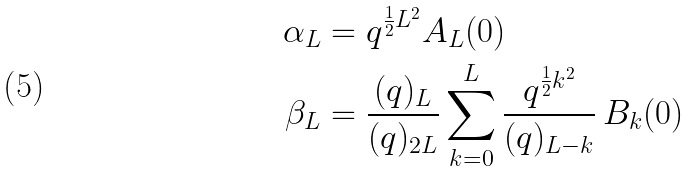Convert formula to latex. <formula><loc_0><loc_0><loc_500><loc_500>\alpha _ { L } & = q ^ { \frac { 1 } { 2 } L ^ { 2 } } A _ { L } ( 0 ) \\ \beta _ { L } & = \frac { ( q ) _ { L } } { ( q ) _ { 2 L } } \sum _ { k = 0 } ^ { L } \frac { q ^ { \frac { 1 } { 2 } k ^ { 2 } } } { ( q ) _ { L - k } } \, B _ { k } ( 0 )</formula> 